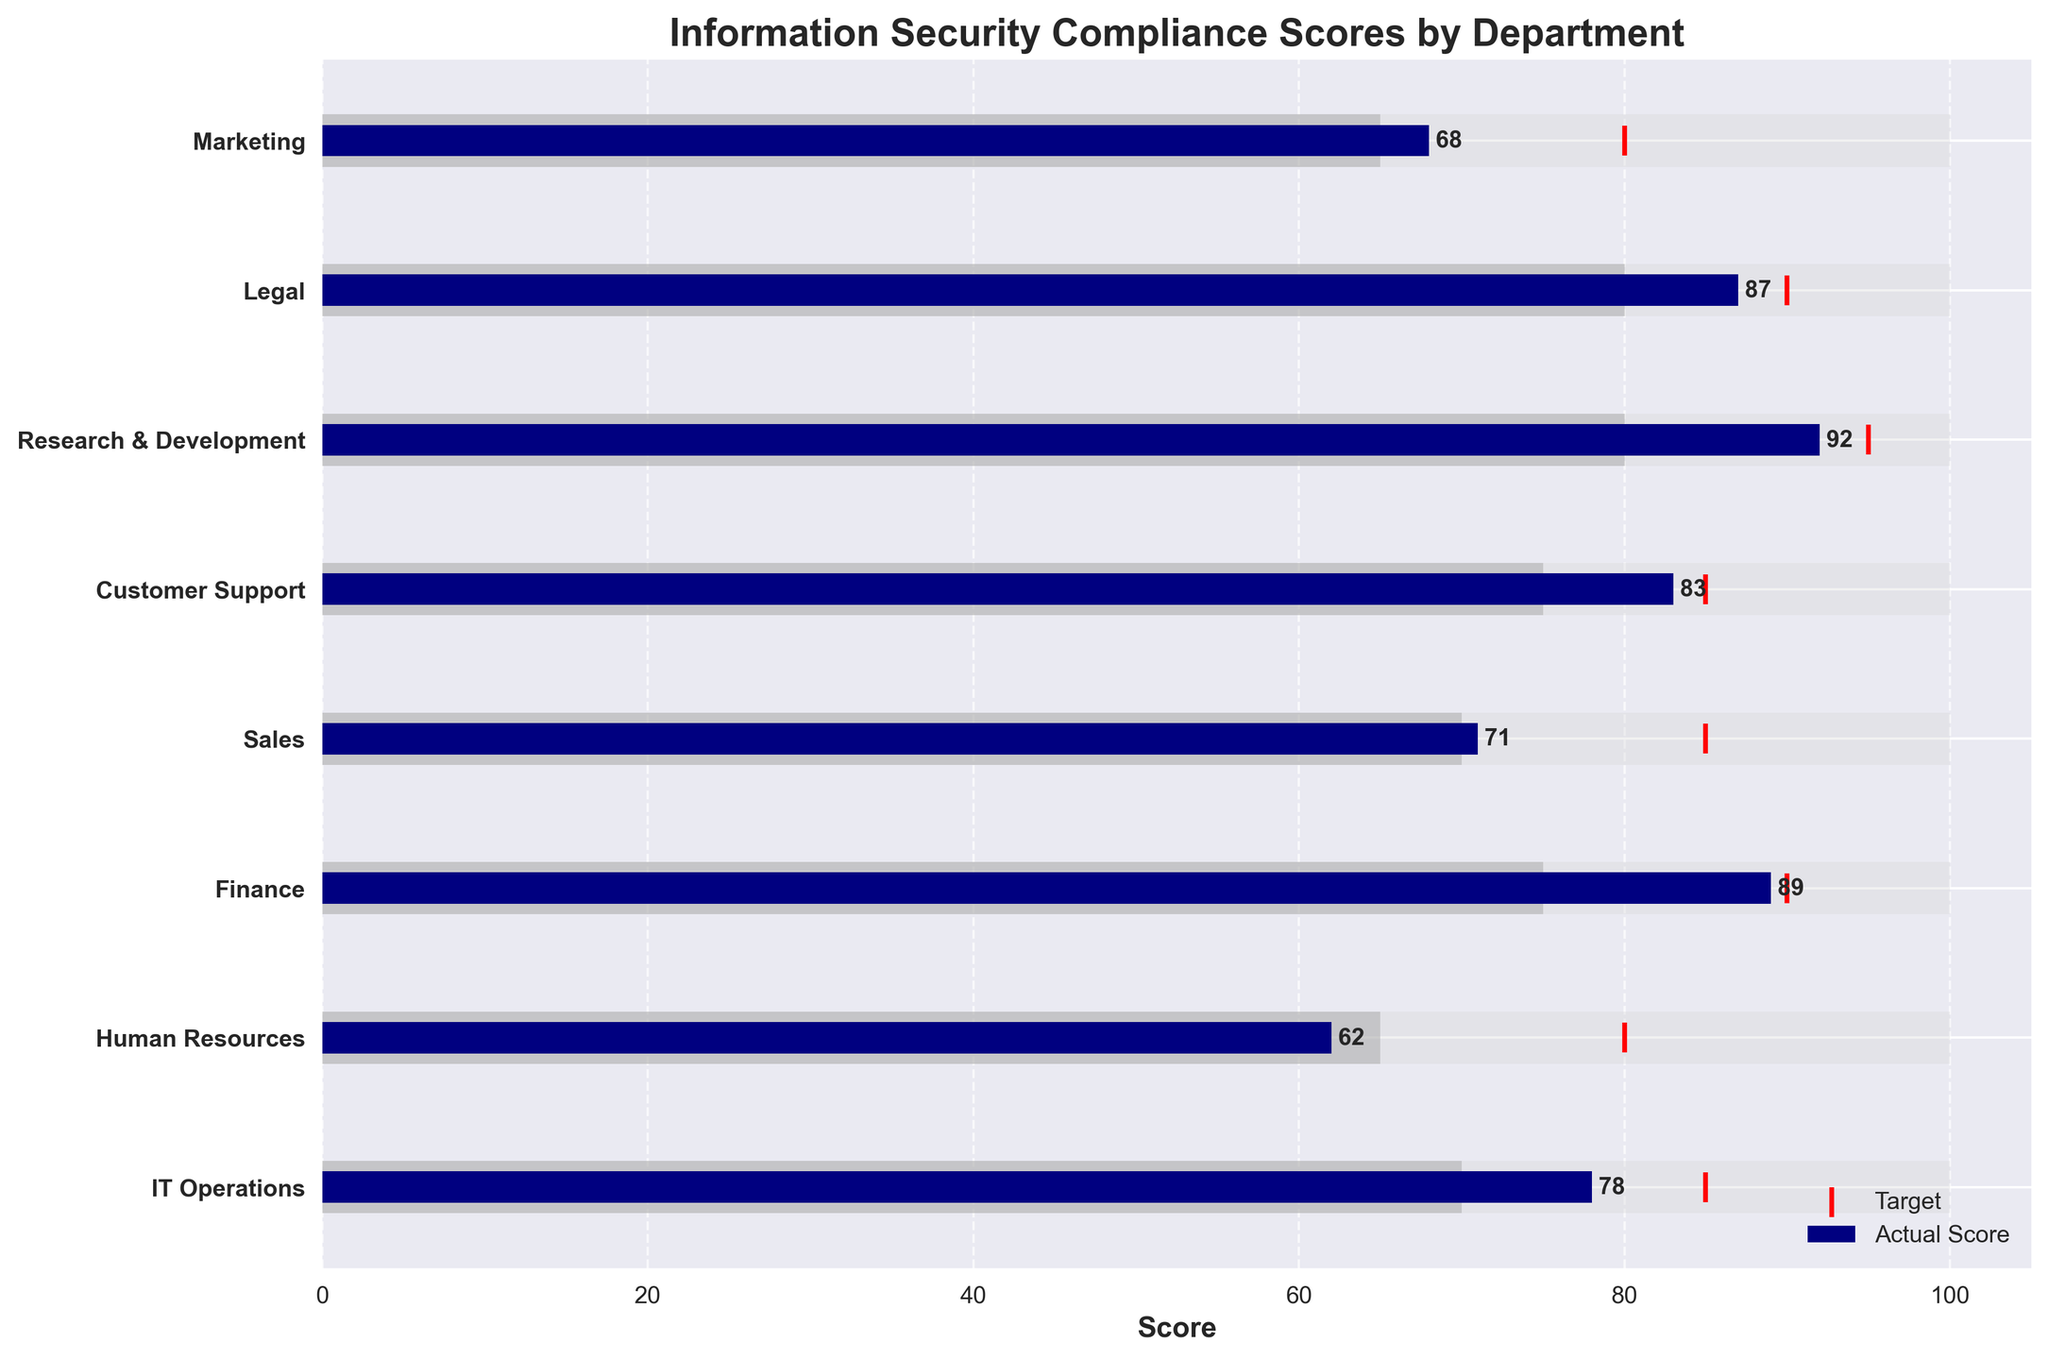What's the highest compliance score achieved by any department? The highest value on the Actual Score bars represents the highest compliance score. Research & Development has a score of 92, which is the highest.
Answer: 92 Which department has the lowest compliance score? The lowest value on the Actual Score bars represents the lowest compliance score. Human Resources has a score of 62, which is the lowest.
Answer: 62 How many departments have an actual score lower than their target? We should count the departments where the blue Actual Score bar is shorter than the red Target marker. Those departments are IT Operations, Human Resources, Sales, Customer Support, and Marketing.
Answer: 5 Which department has the widest gap between its actual score and target? We need to find the department with the largest difference between the blue bar (Actual Score) and the red marker (Target). Human Resources has the widest gap, with a Target of 80 and an Actual Score of 62.
Answer: Human Resources Do any departments have an actual score that exceeds their maximum value? Check if any Actual Score bars exceed the length of the background light grey bars representing the maximum value. No department's actual score exceeds 100.
Answer: No What is the average actual compliance score across all departments? Add up all Actual Scores and divide by the number of departments. (78 + 62 + 89 + 71 + 83 + 92 + 87 + 68) / 8 = 630 / 8 = 78.75
Answer: 78.75 Which departments have achieved at least their target score? Look for departments where the blue Actual Score bar reaches or passes the red Target marker. These departments are Finance, Research & Development, and Legal.
Answer: 3 What is the range of compliance scores across all departments? Find the difference between the highest and lowest Actual Scores. Research & Development has the highest score (92), and Human Resources has the lowest (62). 92 - 62 = 30
Answer: 30 How many departments have an actual score that falls below the threshold? Count departments where the blue Actual Score bar is shorter than the dark grey Threshold bar. Human Resources and Marketing have scores below the threshold.
Answer: 2 Which department has the smallest gap between its actual score and its target? Find the department with the smallest difference between the blue bar (Actual Score) and the red marker (Target). Legal has the smallest gap, with a Target of 90 and an Actual Score of 87.
Answer: Legal 